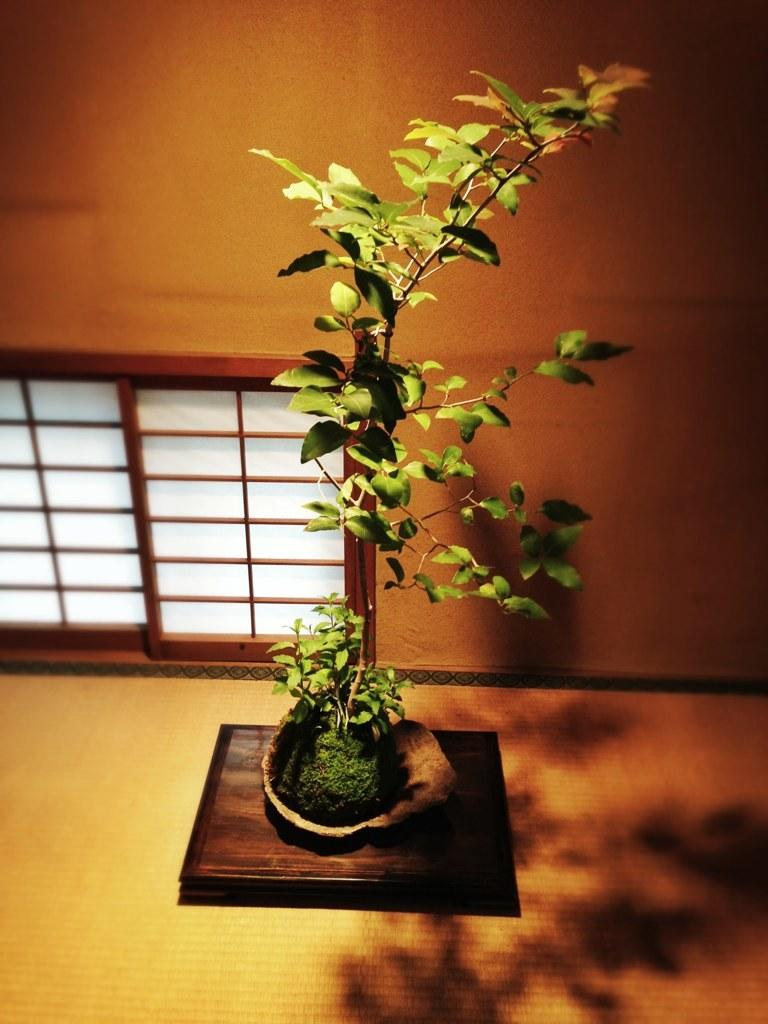What is the main subject in the image? There is a plant in the image. Where is the plant located in relation to the image? The plant is in the front of the image. What can be seen on the ground in the image? There is a shadow on the ground in the image. What architectural feature is present on the left side of the image? There is a window on the left side of the image. How many babies are crawling on the plant in the image? There are no babies present in the image; it features a plant with a shadow on the ground and a window on the left side. 